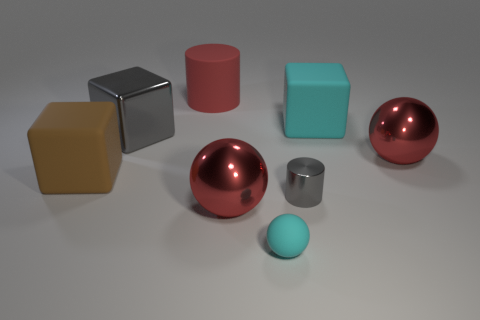Subtract all big gray blocks. How many blocks are left? 2 Add 2 yellow matte cylinders. How many objects exist? 10 Subtract all balls. How many objects are left? 5 Subtract 1 blocks. How many blocks are left? 2 Subtract all gray cylinders. How many cylinders are left? 1 Subtract 0 green cylinders. How many objects are left? 8 Subtract all blue blocks. Subtract all cyan balls. How many blocks are left? 3 Subtract all yellow balls. How many brown cylinders are left? 0 Subtract all large gray metallic cubes. Subtract all brown matte spheres. How many objects are left? 7 Add 4 big metallic balls. How many big metallic balls are left? 6 